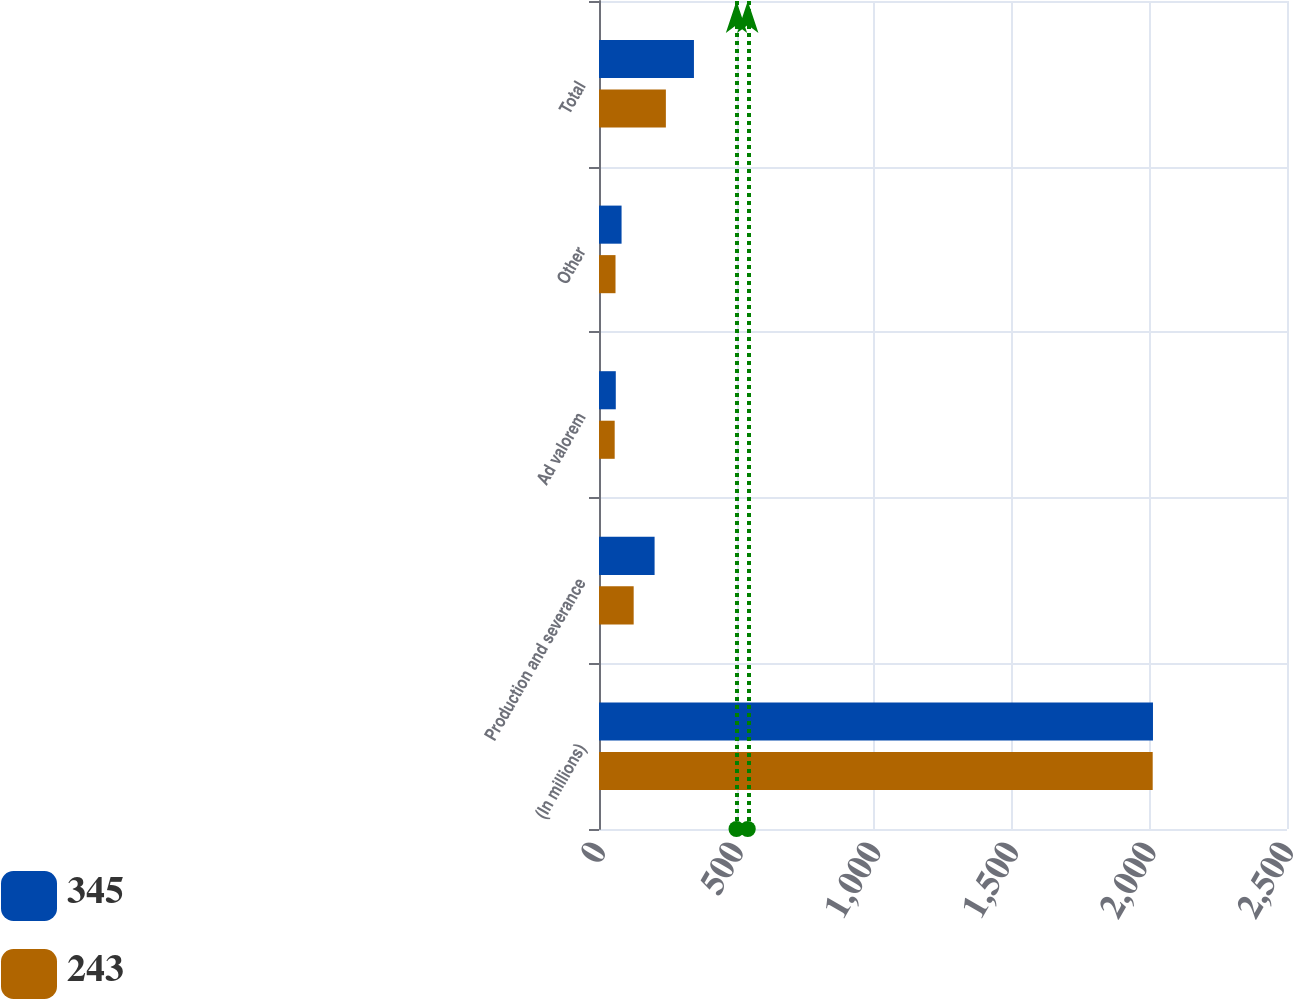<chart> <loc_0><loc_0><loc_500><loc_500><stacked_bar_chart><ecel><fcel>(In millions)<fcel>Production and severance<fcel>Ad valorem<fcel>Other<fcel>Total<nl><fcel>345<fcel>2013<fcel>202<fcel>61<fcel>82<fcel>345<nl><fcel>243<fcel>2012<fcel>126<fcel>57<fcel>60<fcel>243<nl></chart> 